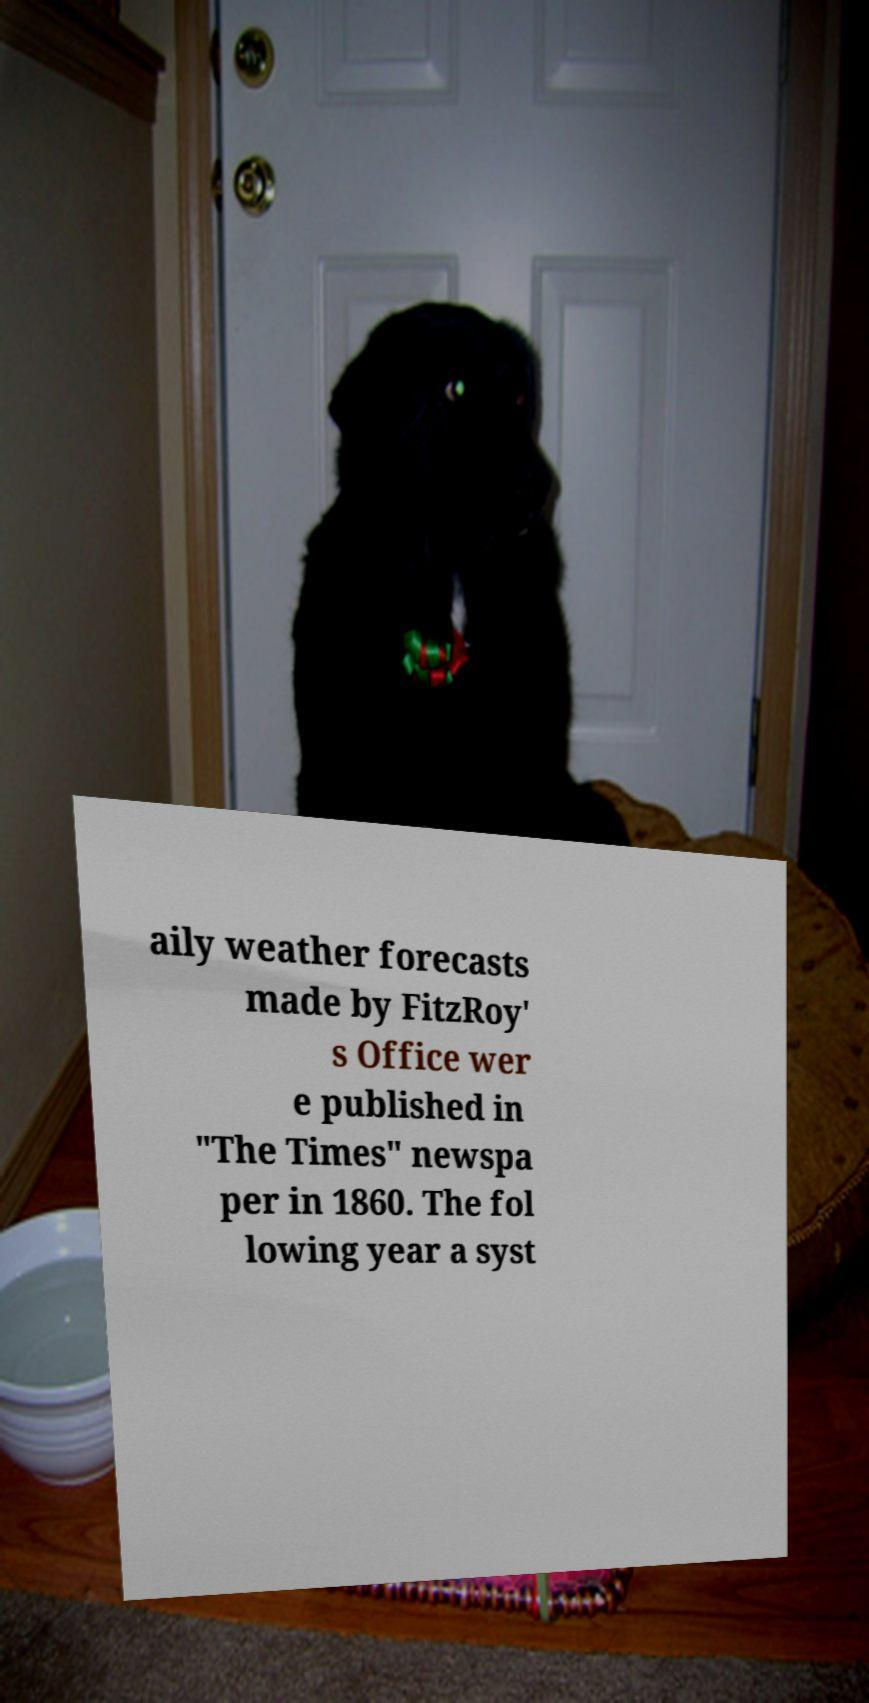There's text embedded in this image that I need extracted. Can you transcribe it verbatim? aily weather forecasts made by FitzRoy' s Office wer e published in "The Times" newspa per in 1860. The fol lowing year a syst 